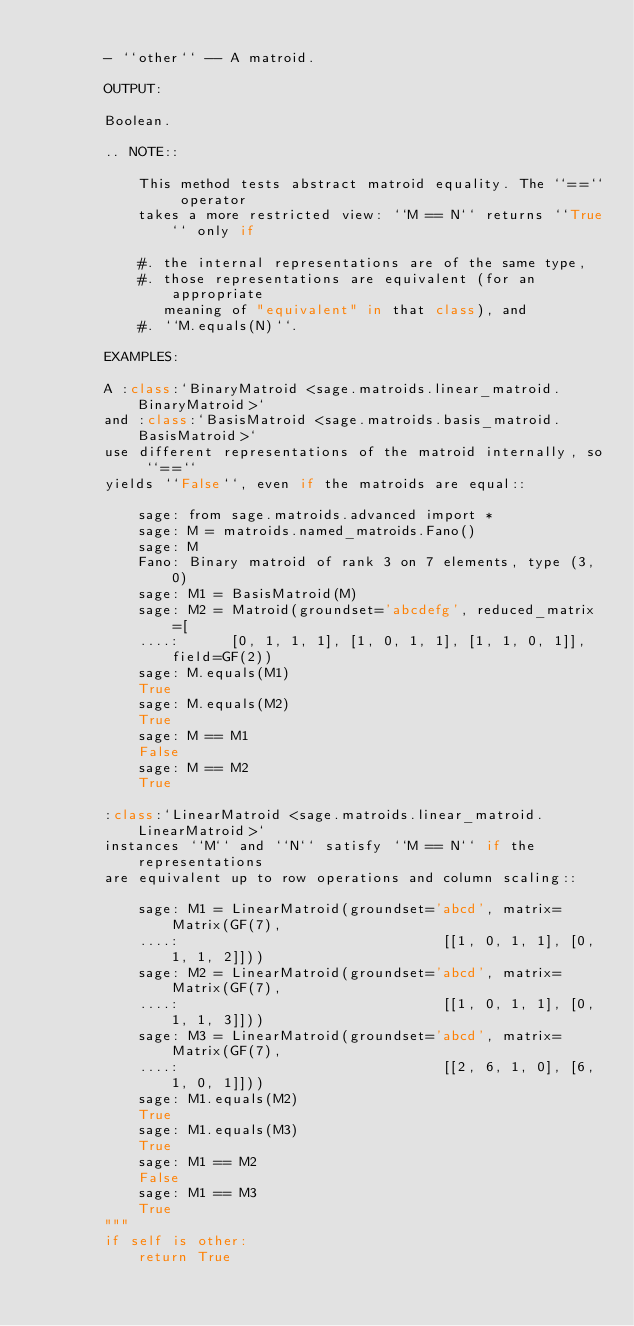<code> <loc_0><loc_0><loc_500><loc_500><_Cython_>
        - ``other`` -- A matroid.

        OUTPUT:

        Boolean.

        .. NOTE::

            This method tests abstract matroid equality. The ``==`` operator
            takes a more restricted view: ``M == N`` returns ``True`` only if

            #. the internal representations are of the same type,
            #. those representations are equivalent (for an appropriate
               meaning of "equivalent" in that class), and
            #. ``M.equals(N)``.

        EXAMPLES:

        A :class:`BinaryMatroid <sage.matroids.linear_matroid.BinaryMatroid>`
        and :class:`BasisMatroid <sage.matroids.basis_matroid.BasisMatroid>`
        use different representations of the matroid internally, so ``==``
        yields ``False``, even if the matroids are equal::

            sage: from sage.matroids.advanced import *
            sage: M = matroids.named_matroids.Fano()
            sage: M
            Fano: Binary matroid of rank 3 on 7 elements, type (3, 0)
            sage: M1 = BasisMatroid(M)
            sage: M2 = Matroid(groundset='abcdefg', reduced_matrix=[
            ....:      [0, 1, 1, 1], [1, 0, 1, 1], [1, 1, 0, 1]], field=GF(2))
            sage: M.equals(M1)
            True
            sage: M.equals(M2)
            True
            sage: M == M1
            False
            sage: M == M2
            True

        :class:`LinearMatroid <sage.matroids.linear_matroid.LinearMatroid>`
        instances ``M`` and ``N`` satisfy ``M == N`` if the representations
        are equivalent up to row operations and column scaling::

            sage: M1 = LinearMatroid(groundset='abcd', matrix=Matrix(GF(7),
            ....:                               [[1, 0, 1, 1], [0, 1, 1, 2]]))
            sage: M2 = LinearMatroid(groundset='abcd', matrix=Matrix(GF(7),
            ....:                               [[1, 0, 1, 1], [0, 1, 1, 3]]))
            sage: M3 = LinearMatroid(groundset='abcd', matrix=Matrix(GF(7),
            ....:                               [[2, 6, 1, 0], [6, 1, 0, 1]]))
            sage: M1.equals(M2)
            True
            sage: M1.equals(M3)
            True
            sage: M1 == M2
            False
            sage: M1 == M3
            True
        """
        if self is other:
            return True</code> 